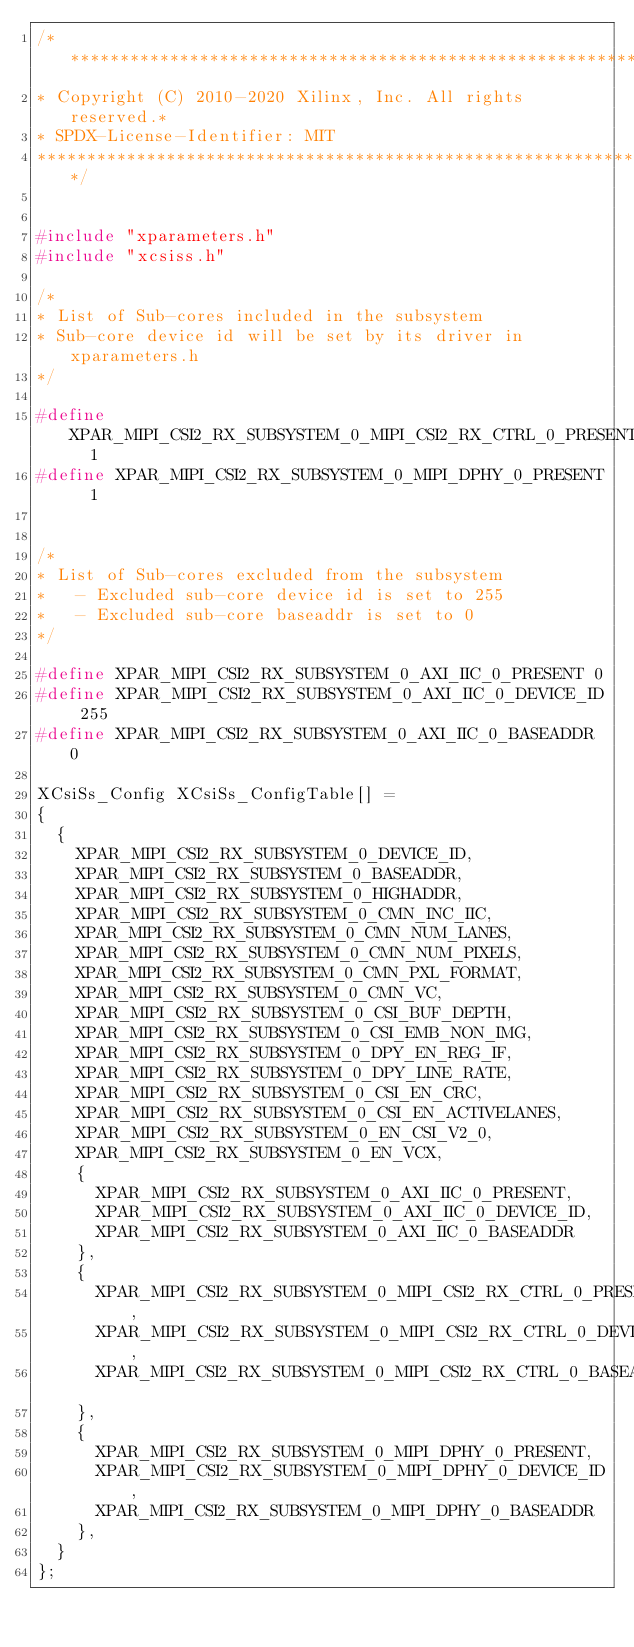<code> <loc_0><loc_0><loc_500><loc_500><_C_>/*******************************************************************
* Copyright (C) 2010-2020 Xilinx, Inc. All rights reserved.*
* SPDX-License-Identifier: MIT
*******************************************************************************/


#include "xparameters.h"
#include "xcsiss.h"

/*
* List of Sub-cores included in the subsystem
* Sub-core device id will be set by its driver in xparameters.h
*/

#define XPAR_MIPI_CSI2_RX_SUBSYSTEM_0_MIPI_CSI2_RX_CTRL_0_PRESENT	 1
#define XPAR_MIPI_CSI2_RX_SUBSYSTEM_0_MIPI_DPHY_0_PRESENT	 1


/*
* List of Sub-cores excluded from the subsystem
*   - Excluded sub-core device id is set to 255
*   - Excluded sub-core baseaddr is set to 0
*/

#define XPAR_MIPI_CSI2_RX_SUBSYSTEM_0_AXI_IIC_0_PRESENT 0
#define XPAR_MIPI_CSI2_RX_SUBSYSTEM_0_AXI_IIC_0_DEVICE_ID 255
#define XPAR_MIPI_CSI2_RX_SUBSYSTEM_0_AXI_IIC_0_BASEADDR 0

XCsiSs_Config XCsiSs_ConfigTable[] =
{
	{
		XPAR_MIPI_CSI2_RX_SUBSYSTEM_0_DEVICE_ID,
		XPAR_MIPI_CSI2_RX_SUBSYSTEM_0_BASEADDR,
		XPAR_MIPI_CSI2_RX_SUBSYSTEM_0_HIGHADDR,
		XPAR_MIPI_CSI2_RX_SUBSYSTEM_0_CMN_INC_IIC,
		XPAR_MIPI_CSI2_RX_SUBSYSTEM_0_CMN_NUM_LANES,
		XPAR_MIPI_CSI2_RX_SUBSYSTEM_0_CMN_NUM_PIXELS,
		XPAR_MIPI_CSI2_RX_SUBSYSTEM_0_CMN_PXL_FORMAT,
		XPAR_MIPI_CSI2_RX_SUBSYSTEM_0_CMN_VC,
		XPAR_MIPI_CSI2_RX_SUBSYSTEM_0_CSI_BUF_DEPTH,
		XPAR_MIPI_CSI2_RX_SUBSYSTEM_0_CSI_EMB_NON_IMG,
		XPAR_MIPI_CSI2_RX_SUBSYSTEM_0_DPY_EN_REG_IF,
		XPAR_MIPI_CSI2_RX_SUBSYSTEM_0_DPY_LINE_RATE,
		XPAR_MIPI_CSI2_RX_SUBSYSTEM_0_CSI_EN_CRC,
		XPAR_MIPI_CSI2_RX_SUBSYSTEM_0_CSI_EN_ACTIVELANES,
		XPAR_MIPI_CSI2_RX_SUBSYSTEM_0_EN_CSI_V2_0,
		XPAR_MIPI_CSI2_RX_SUBSYSTEM_0_EN_VCX,
		{
			XPAR_MIPI_CSI2_RX_SUBSYSTEM_0_AXI_IIC_0_PRESENT,
			XPAR_MIPI_CSI2_RX_SUBSYSTEM_0_AXI_IIC_0_DEVICE_ID,
			XPAR_MIPI_CSI2_RX_SUBSYSTEM_0_AXI_IIC_0_BASEADDR
		},
		{
			XPAR_MIPI_CSI2_RX_SUBSYSTEM_0_MIPI_CSI2_RX_CTRL_0_PRESENT,
			XPAR_MIPI_CSI2_RX_SUBSYSTEM_0_MIPI_CSI2_RX_CTRL_0_DEVICE_ID,
			XPAR_MIPI_CSI2_RX_SUBSYSTEM_0_MIPI_CSI2_RX_CTRL_0_BASEADDR
		},
		{
			XPAR_MIPI_CSI2_RX_SUBSYSTEM_0_MIPI_DPHY_0_PRESENT,
			XPAR_MIPI_CSI2_RX_SUBSYSTEM_0_MIPI_DPHY_0_DEVICE_ID,
			XPAR_MIPI_CSI2_RX_SUBSYSTEM_0_MIPI_DPHY_0_BASEADDR
		},
	}
};
</code> 